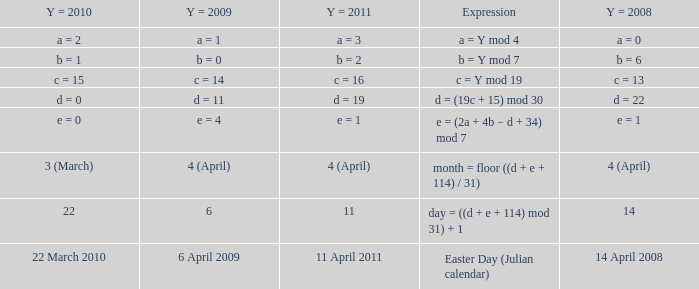What is the y = 2011 when the expression is month = floor ((d + e + 114) / 31)? 4 (April). Help me parse the entirety of this table. {'header': ['Y = 2010', 'Y = 2009', 'Y = 2011', 'Expression', 'Y = 2008'], 'rows': [['a = 2', 'a = 1', 'a = 3', 'a = Y mod 4', 'a = 0'], ['b = 1', 'b = 0', 'b = 2', 'b = Y mod 7', 'b = 6'], ['c = 15', 'c = 14', 'c = 16', 'c = Y mod 19', 'c = 13'], ['d = 0', 'd = 11', 'd = 19', 'd = (19c + 15) mod 30', 'd = 22'], ['e = 0', 'e = 4', 'e = 1', 'e = (2a + 4b − d + 34) mod 7', 'e = 1'], ['3 (March)', '4 (April)', '4 (April)', 'month = floor ((d + e + 114) / 31)', '4 (April)'], ['22', '6', '11', 'day = ((d + e + 114) mod 31) + 1', '14'], ['22 March 2010', '6 April 2009', '11 April 2011', 'Easter Day (Julian calendar)', '14 April 2008']]} 